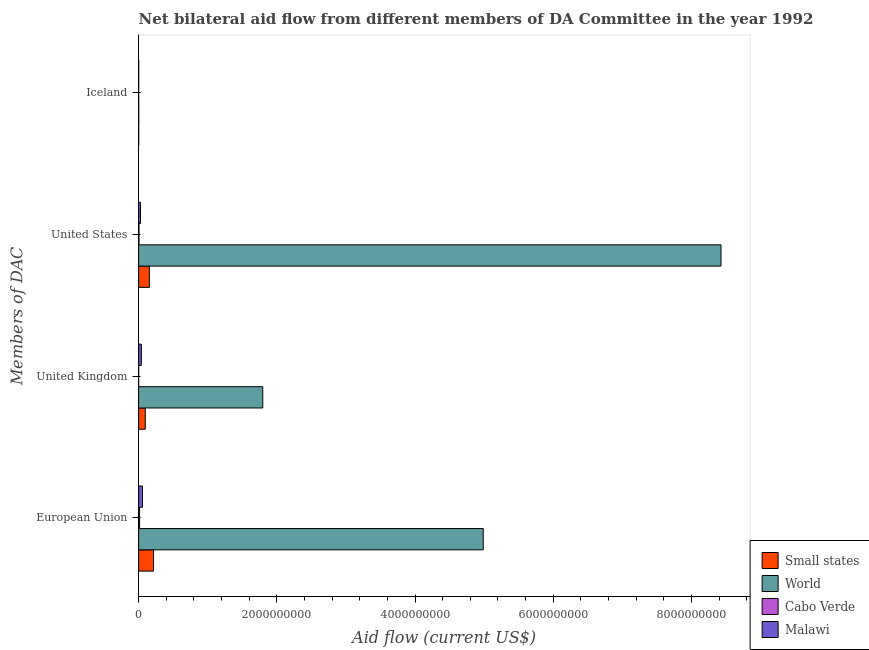How many groups of bars are there?
Your answer should be very brief. 4. Are the number of bars on each tick of the Y-axis equal?
Your answer should be very brief. Yes. How many bars are there on the 3rd tick from the bottom?
Give a very brief answer. 4. What is the label of the 2nd group of bars from the top?
Provide a succinct answer. United States. What is the amount of aid given by us in Malawi?
Keep it short and to the point. 2.70e+07. Across all countries, what is the maximum amount of aid given by iceland?
Offer a terse response. 1.85e+06. Across all countries, what is the minimum amount of aid given by eu?
Provide a succinct answer. 1.36e+07. In which country was the amount of aid given by eu maximum?
Your answer should be very brief. World. In which country was the amount of aid given by uk minimum?
Provide a short and direct response. Cabo Verde. What is the total amount of aid given by eu in the graph?
Give a very brief answer. 5.27e+09. What is the difference between the amount of aid given by eu in Malawi and that in Small states?
Offer a terse response. -1.60e+08. What is the difference between the amount of aid given by uk in Small states and the amount of aid given by us in Cabo Verde?
Your response must be concise. 9.11e+07. What is the average amount of aid given by uk per country?
Provide a succinct answer. 4.83e+08. What is the difference between the amount of aid given by iceland and amount of aid given by us in World?
Your answer should be compact. -8.43e+09. What is the difference between the highest and the second highest amount of aid given by iceland?
Your answer should be very brief. 1.05e+06. What is the difference between the highest and the lowest amount of aid given by eu?
Make the answer very short. 4.97e+09. In how many countries, is the amount of aid given by eu greater than the average amount of aid given by eu taken over all countries?
Keep it short and to the point. 1. What does the 3rd bar from the top in United States represents?
Make the answer very short. World. What does the 4th bar from the bottom in Iceland represents?
Your answer should be compact. Malawi. Is it the case that in every country, the sum of the amount of aid given by eu and amount of aid given by uk is greater than the amount of aid given by us?
Make the answer very short. No. How many countries are there in the graph?
Give a very brief answer. 4. What is the difference between two consecutive major ticks on the X-axis?
Your response must be concise. 2.00e+09. Are the values on the major ticks of X-axis written in scientific E-notation?
Offer a terse response. No. Does the graph contain any zero values?
Give a very brief answer. No. Where does the legend appear in the graph?
Your answer should be very brief. Bottom right. How many legend labels are there?
Make the answer very short. 4. What is the title of the graph?
Keep it short and to the point. Net bilateral aid flow from different members of DA Committee in the year 1992. What is the label or title of the X-axis?
Make the answer very short. Aid flow (current US$). What is the label or title of the Y-axis?
Make the answer very short. Members of DAC. What is the Aid flow (current US$) in Small states in European Union?
Your answer should be compact. 2.16e+08. What is the Aid flow (current US$) in World in European Union?
Provide a succinct answer. 4.99e+09. What is the Aid flow (current US$) of Cabo Verde in European Union?
Give a very brief answer. 1.36e+07. What is the Aid flow (current US$) of Malawi in European Union?
Keep it short and to the point. 5.60e+07. What is the Aid flow (current US$) of Small states in United Kingdom?
Offer a terse response. 9.61e+07. What is the Aid flow (current US$) in World in United Kingdom?
Provide a succinct answer. 1.80e+09. What is the Aid flow (current US$) in Malawi in United Kingdom?
Make the answer very short. 3.95e+07. What is the Aid flow (current US$) of Small states in United States?
Provide a succinct answer. 1.55e+08. What is the Aid flow (current US$) in World in United States?
Your answer should be compact. 8.43e+09. What is the Aid flow (current US$) in Malawi in United States?
Make the answer very short. 2.70e+07. What is the Aid flow (current US$) in World in Iceland?
Your answer should be very brief. 1.85e+06. What is the Aid flow (current US$) of Cabo Verde in Iceland?
Your response must be concise. 1.00e+05. What is the Aid flow (current US$) of Malawi in Iceland?
Ensure brevity in your answer.  7.50e+05. Across all Members of DAC, what is the maximum Aid flow (current US$) of Small states?
Provide a succinct answer. 2.16e+08. Across all Members of DAC, what is the maximum Aid flow (current US$) in World?
Ensure brevity in your answer.  8.43e+09. Across all Members of DAC, what is the maximum Aid flow (current US$) of Cabo Verde?
Provide a succinct answer. 1.36e+07. Across all Members of DAC, what is the maximum Aid flow (current US$) in Malawi?
Offer a very short reply. 5.60e+07. Across all Members of DAC, what is the minimum Aid flow (current US$) of World?
Your answer should be very brief. 1.85e+06. Across all Members of DAC, what is the minimum Aid flow (current US$) of Malawi?
Offer a terse response. 7.50e+05. What is the total Aid flow (current US$) of Small states in the graph?
Keep it short and to the point. 4.68e+08. What is the total Aid flow (current US$) in World in the graph?
Your answer should be very brief. 1.52e+1. What is the total Aid flow (current US$) of Cabo Verde in the graph?
Offer a terse response. 1.88e+07. What is the total Aid flow (current US$) in Malawi in the graph?
Your answer should be compact. 1.23e+08. What is the difference between the Aid flow (current US$) of Small states in European Union and that in United Kingdom?
Offer a terse response. 1.20e+08. What is the difference between the Aid flow (current US$) in World in European Union and that in United Kingdom?
Provide a succinct answer. 3.19e+09. What is the difference between the Aid flow (current US$) in Cabo Verde in European Union and that in United Kingdom?
Provide a succinct answer. 1.34e+07. What is the difference between the Aid flow (current US$) in Malawi in European Union and that in United Kingdom?
Make the answer very short. 1.65e+07. What is the difference between the Aid flow (current US$) in Small states in European Union and that in United States?
Your answer should be very brief. 6.07e+07. What is the difference between the Aid flow (current US$) of World in European Union and that in United States?
Your answer should be very brief. -3.44e+09. What is the difference between the Aid flow (current US$) in Cabo Verde in European Union and that in United States?
Offer a terse response. 8.55e+06. What is the difference between the Aid flow (current US$) in Malawi in European Union and that in United States?
Your response must be concise. 2.90e+07. What is the difference between the Aid flow (current US$) of Small states in European Union and that in Iceland?
Give a very brief answer. 2.15e+08. What is the difference between the Aid flow (current US$) in World in European Union and that in Iceland?
Keep it short and to the point. 4.99e+09. What is the difference between the Aid flow (current US$) in Cabo Verde in European Union and that in Iceland?
Your response must be concise. 1.34e+07. What is the difference between the Aid flow (current US$) in Malawi in European Union and that in Iceland?
Provide a succinct answer. 5.52e+07. What is the difference between the Aid flow (current US$) of Small states in United Kingdom and that in United States?
Ensure brevity in your answer.  -5.89e+07. What is the difference between the Aid flow (current US$) in World in United Kingdom and that in United States?
Your response must be concise. -6.63e+09. What is the difference between the Aid flow (current US$) of Cabo Verde in United Kingdom and that in United States?
Your answer should be very brief. -4.80e+06. What is the difference between the Aid flow (current US$) of Malawi in United Kingdom and that in United States?
Your answer should be compact. 1.25e+07. What is the difference between the Aid flow (current US$) of Small states in United Kingdom and that in Iceland?
Your response must be concise. 9.53e+07. What is the difference between the Aid flow (current US$) of World in United Kingdom and that in Iceland?
Ensure brevity in your answer.  1.79e+09. What is the difference between the Aid flow (current US$) in Malawi in United Kingdom and that in Iceland?
Make the answer very short. 3.87e+07. What is the difference between the Aid flow (current US$) in Small states in United States and that in Iceland?
Offer a very short reply. 1.54e+08. What is the difference between the Aid flow (current US$) of World in United States and that in Iceland?
Provide a succinct answer. 8.43e+09. What is the difference between the Aid flow (current US$) in Cabo Verde in United States and that in Iceland?
Provide a succinct answer. 4.90e+06. What is the difference between the Aid flow (current US$) in Malawi in United States and that in Iceland?
Give a very brief answer. 2.62e+07. What is the difference between the Aid flow (current US$) in Small states in European Union and the Aid flow (current US$) in World in United Kingdom?
Provide a succinct answer. -1.58e+09. What is the difference between the Aid flow (current US$) in Small states in European Union and the Aid flow (current US$) in Cabo Verde in United Kingdom?
Provide a short and direct response. 2.16e+08. What is the difference between the Aid flow (current US$) of Small states in European Union and the Aid flow (current US$) of Malawi in United Kingdom?
Make the answer very short. 1.76e+08. What is the difference between the Aid flow (current US$) of World in European Union and the Aid flow (current US$) of Cabo Verde in United Kingdom?
Offer a terse response. 4.99e+09. What is the difference between the Aid flow (current US$) of World in European Union and the Aid flow (current US$) of Malawi in United Kingdom?
Your response must be concise. 4.95e+09. What is the difference between the Aid flow (current US$) in Cabo Verde in European Union and the Aid flow (current US$) in Malawi in United Kingdom?
Keep it short and to the point. -2.59e+07. What is the difference between the Aid flow (current US$) in Small states in European Union and the Aid flow (current US$) in World in United States?
Ensure brevity in your answer.  -8.21e+09. What is the difference between the Aid flow (current US$) in Small states in European Union and the Aid flow (current US$) in Cabo Verde in United States?
Your answer should be compact. 2.11e+08. What is the difference between the Aid flow (current US$) of Small states in European Union and the Aid flow (current US$) of Malawi in United States?
Offer a terse response. 1.89e+08. What is the difference between the Aid flow (current US$) in World in European Union and the Aid flow (current US$) in Cabo Verde in United States?
Offer a very short reply. 4.98e+09. What is the difference between the Aid flow (current US$) of World in European Union and the Aid flow (current US$) of Malawi in United States?
Provide a short and direct response. 4.96e+09. What is the difference between the Aid flow (current US$) of Cabo Verde in European Union and the Aid flow (current US$) of Malawi in United States?
Make the answer very short. -1.34e+07. What is the difference between the Aid flow (current US$) in Small states in European Union and the Aid flow (current US$) in World in Iceland?
Offer a very short reply. 2.14e+08. What is the difference between the Aid flow (current US$) of Small states in European Union and the Aid flow (current US$) of Cabo Verde in Iceland?
Make the answer very short. 2.16e+08. What is the difference between the Aid flow (current US$) of Small states in European Union and the Aid flow (current US$) of Malawi in Iceland?
Your answer should be very brief. 2.15e+08. What is the difference between the Aid flow (current US$) in World in European Union and the Aid flow (current US$) in Cabo Verde in Iceland?
Provide a short and direct response. 4.99e+09. What is the difference between the Aid flow (current US$) of World in European Union and the Aid flow (current US$) of Malawi in Iceland?
Provide a succinct answer. 4.99e+09. What is the difference between the Aid flow (current US$) in Cabo Verde in European Union and the Aid flow (current US$) in Malawi in Iceland?
Ensure brevity in your answer.  1.28e+07. What is the difference between the Aid flow (current US$) of Small states in United Kingdom and the Aid flow (current US$) of World in United States?
Give a very brief answer. -8.33e+09. What is the difference between the Aid flow (current US$) in Small states in United Kingdom and the Aid flow (current US$) in Cabo Verde in United States?
Your answer should be very brief. 9.11e+07. What is the difference between the Aid flow (current US$) in Small states in United Kingdom and the Aid flow (current US$) in Malawi in United States?
Keep it short and to the point. 6.91e+07. What is the difference between the Aid flow (current US$) of World in United Kingdom and the Aid flow (current US$) of Cabo Verde in United States?
Your answer should be compact. 1.79e+09. What is the difference between the Aid flow (current US$) of World in United Kingdom and the Aid flow (current US$) of Malawi in United States?
Make the answer very short. 1.77e+09. What is the difference between the Aid flow (current US$) of Cabo Verde in United Kingdom and the Aid flow (current US$) of Malawi in United States?
Your answer should be compact. -2.68e+07. What is the difference between the Aid flow (current US$) in Small states in United Kingdom and the Aid flow (current US$) in World in Iceland?
Offer a very short reply. 9.43e+07. What is the difference between the Aid flow (current US$) in Small states in United Kingdom and the Aid flow (current US$) in Cabo Verde in Iceland?
Give a very brief answer. 9.60e+07. What is the difference between the Aid flow (current US$) of Small states in United Kingdom and the Aid flow (current US$) of Malawi in Iceland?
Make the answer very short. 9.54e+07. What is the difference between the Aid flow (current US$) of World in United Kingdom and the Aid flow (current US$) of Cabo Verde in Iceland?
Your answer should be compact. 1.80e+09. What is the difference between the Aid flow (current US$) in World in United Kingdom and the Aid flow (current US$) in Malawi in Iceland?
Your response must be concise. 1.80e+09. What is the difference between the Aid flow (current US$) in Cabo Verde in United Kingdom and the Aid flow (current US$) in Malawi in Iceland?
Your response must be concise. -5.50e+05. What is the difference between the Aid flow (current US$) in Small states in United States and the Aid flow (current US$) in World in Iceland?
Offer a terse response. 1.53e+08. What is the difference between the Aid flow (current US$) of Small states in United States and the Aid flow (current US$) of Cabo Verde in Iceland?
Give a very brief answer. 1.55e+08. What is the difference between the Aid flow (current US$) of Small states in United States and the Aid flow (current US$) of Malawi in Iceland?
Your response must be concise. 1.54e+08. What is the difference between the Aid flow (current US$) of World in United States and the Aid flow (current US$) of Cabo Verde in Iceland?
Make the answer very short. 8.43e+09. What is the difference between the Aid flow (current US$) of World in United States and the Aid flow (current US$) of Malawi in Iceland?
Make the answer very short. 8.43e+09. What is the difference between the Aid flow (current US$) of Cabo Verde in United States and the Aid flow (current US$) of Malawi in Iceland?
Offer a terse response. 4.25e+06. What is the average Aid flow (current US$) in Small states per Members of DAC?
Your response must be concise. 1.17e+08. What is the average Aid flow (current US$) in World per Members of DAC?
Offer a very short reply. 3.80e+09. What is the average Aid flow (current US$) in Cabo Verde per Members of DAC?
Your answer should be compact. 4.71e+06. What is the average Aid flow (current US$) of Malawi per Members of DAC?
Make the answer very short. 3.08e+07. What is the difference between the Aid flow (current US$) in Small states and Aid flow (current US$) in World in European Union?
Your answer should be very brief. -4.77e+09. What is the difference between the Aid flow (current US$) in Small states and Aid flow (current US$) in Cabo Verde in European Union?
Your answer should be very brief. 2.02e+08. What is the difference between the Aid flow (current US$) of Small states and Aid flow (current US$) of Malawi in European Union?
Ensure brevity in your answer.  1.60e+08. What is the difference between the Aid flow (current US$) of World and Aid flow (current US$) of Cabo Verde in European Union?
Your response must be concise. 4.97e+09. What is the difference between the Aid flow (current US$) of World and Aid flow (current US$) of Malawi in European Union?
Offer a terse response. 4.93e+09. What is the difference between the Aid flow (current US$) in Cabo Verde and Aid flow (current US$) in Malawi in European Union?
Your answer should be very brief. -4.24e+07. What is the difference between the Aid flow (current US$) of Small states and Aid flow (current US$) of World in United Kingdom?
Provide a short and direct response. -1.70e+09. What is the difference between the Aid flow (current US$) of Small states and Aid flow (current US$) of Cabo Verde in United Kingdom?
Give a very brief answer. 9.59e+07. What is the difference between the Aid flow (current US$) in Small states and Aid flow (current US$) in Malawi in United Kingdom?
Keep it short and to the point. 5.66e+07. What is the difference between the Aid flow (current US$) in World and Aid flow (current US$) in Cabo Verde in United Kingdom?
Your response must be concise. 1.80e+09. What is the difference between the Aid flow (current US$) of World and Aid flow (current US$) of Malawi in United Kingdom?
Your answer should be very brief. 1.76e+09. What is the difference between the Aid flow (current US$) of Cabo Verde and Aid flow (current US$) of Malawi in United Kingdom?
Provide a short and direct response. -3.93e+07. What is the difference between the Aid flow (current US$) of Small states and Aid flow (current US$) of World in United States?
Provide a succinct answer. -8.27e+09. What is the difference between the Aid flow (current US$) of Small states and Aid flow (current US$) of Cabo Verde in United States?
Your answer should be very brief. 1.50e+08. What is the difference between the Aid flow (current US$) in Small states and Aid flow (current US$) in Malawi in United States?
Make the answer very short. 1.28e+08. What is the difference between the Aid flow (current US$) in World and Aid flow (current US$) in Cabo Verde in United States?
Ensure brevity in your answer.  8.42e+09. What is the difference between the Aid flow (current US$) in World and Aid flow (current US$) in Malawi in United States?
Offer a very short reply. 8.40e+09. What is the difference between the Aid flow (current US$) in Cabo Verde and Aid flow (current US$) in Malawi in United States?
Keep it short and to the point. -2.20e+07. What is the difference between the Aid flow (current US$) of Small states and Aid flow (current US$) of World in Iceland?
Your response must be concise. -1.05e+06. What is the difference between the Aid flow (current US$) in World and Aid flow (current US$) in Cabo Verde in Iceland?
Your answer should be very brief. 1.75e+06. What is the difference between the Aid flow (current US$) of World and Aid flow (current US$) of Malawi in Iceland?
Keep it short and to the point. 1.10e+06. What is the difference between the Aid flow (current US$) of Cabo Verde and Aid flow (current US$) of Malawi in Iceland?
Your response must be concise. -6.50e+05. What is the ratio of the Aid flow (current US$) in Small states in European Union to that in United Kingdom?
Ensure brevity in your answer.  2.24. What is the ratio of the Aid flow (current US$) of World in European Union to that in United Kingdom?
Your response must be concise. 2.78. What is the ratio of the Aid flow (current US$) in Cabo Verde in European Union to that in United Kingdom?
Offer a terse response. 67.75. What is the ratio of the Aid flow (current US$) in Malawi in European Union to that in United Kingdom?
Keep it short and to the point. 1.42. What is the ratio of the Aid flow (current US$) in Small states in European Union to that in United States?
Provide a short and direct response. 1.39. What is the ratio of the Aid flow (current US$) in World in European Union to that in United States?
Your response must be concise. 0.59. What is the ratio of the Aid flow (current US$) of Cabo Verde in European Union to that in United States?
Your response must be concise. 2.71. What is the ratio of the Aid flow (current US$) in Malawi in European Union to that in United States?
Make the answer very short. 2.07. What is the ratio of the Aid flow (current US$) in Small states in European Union to that in Iceland?
Offer a very short reply. 269.64. What is the ratio of the Aid flow (current US$) of World in European Union to that in Iceland?
Your response must be concise. 2696.07. What is the ratio of the Aid flow (current US$) in Cabo Verde in European Union to that in Iceland?
Keep it short and to the point. 135.5. What is the ratio of the Aid flow (current US$) in Malawi in European Union to that in Iceland?
Your response must be concise. 74.61. What is the ratio of the Aid flow (current US$) of Small states in United Kingdom to that in United States?
Offer a terse response. 0.62. What is the ratio of the Aid flow (current US$) of World in United Kingdom to that in United States?
Your answer should be very brief. 0.21. What is the ratio of the Aid flow (current US$) in Cabo Verde in United Kingdom to that in United States?
Give a very brief answer. 0.04. What is the ratio of the Aid flow (current US$) in Malawi in United Kingdom to that in United States?
Give a very brief answer. 1.46. What is the ratio of the Aid flow (current US$) of Small states in United Kingdom to that in Iceland?
Ensure brevity in your answer.  120.14. What is the ratio of the Aid flow (current US$) in World in United Kingdom to that in Iceland?
Keep it short and to the point. 971.03. What is the ratio of the Aid flow (current US$) in Malawi in United Kingdom to that in Iceland?
Provide a short and direct response. 52.61. What is the ratio of the Aid flow (current US$) of Small states in United States to that in Iceland?
Offer a very short reply. 193.75. What is the ratio of the Aid flow (current US$) in World in United States to that in Iceland?
Your answer should be very brief. 4556.22. What is the ratio of the Aid flow (current US$) of Cabo Verde in United States to that in Iceland?
Provide a short and direct response. 50. What is the difference between the highest and the second highest Aid flow (current US$) of Small states?
Your answer should be very brief. 6.07e+07. What is the difference between the highest and the second highest Aid flow (current US$) in World?
Your response must be concise. 3.44e+09. What is the difference between the highest and the second highest Aid flow (current US$) of Cabo Verde?
Offer a very short reply. 8.55e+06. What is the difference between the highest and the second highest Aid flow (current US$) in Malawi?
Provide a succinct answer. 1.65e+07. What is the difference between the highest and the lowest Aid flow (current US$) in Small states?
Provide a short and direct response. 2.15e+08. What is the difference between the highest and the lowest Aid flow (current US$) of World?
Give a very brief answer. 8.43e+09. What is the difference between the highest and the lowest Aid flow (current US$) of Cabo Verde?
Offer a terse response. 1.34e+07. What is the difference between the highest and the lowest Aid flow (current US$) in Malawi?
Make the answer very short. 5.52e+07. 